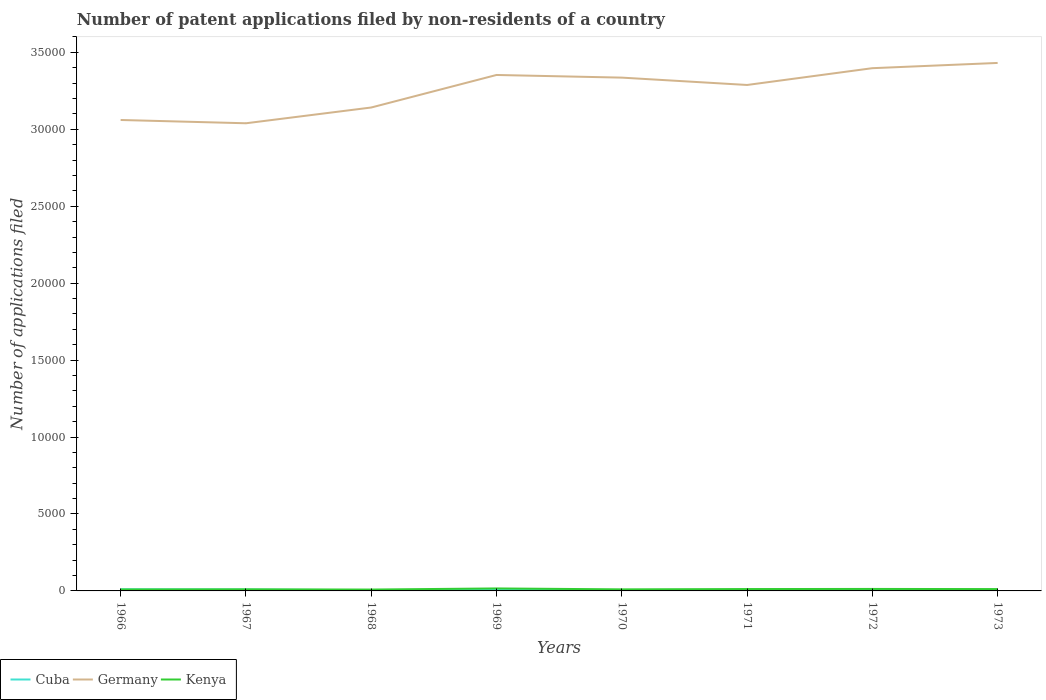Does the line corresponding to Cuba intersect with the line corresponding to Germany?
Your answer should be compact. No. Across all years, what is the maximum number of applications filed in Germany?
Your answer should be very brief. 3.04e+04. In which year was the number of applications filed in Kenya maximum?
Keep it short and to the point. 1968. What is the difference between the highest and the second highest number of applications filed in Germany?
Your answer should be very brief. 3921. How many years are there in the graph?
Provide a short and direct response. 8. Does the graph contain any zero values?
Give a very brief answer. No. Does the graph contain grids?
Offer a terse response. No. Where does the legend appear in the graph?
Your answer should be compact. Bottom left. What is the title of the graph?
Your answer should be compact. Number of patent applications filed by non-residents of a country. What is the label or title of the Y-axis?
Provide a succinct answer. Number of applications filed. What is the Number of applications filed in Cuba in 1966?
Your response must be concise. 106. What is the Number of applications filed of Germany in 1966?
Offer a terse response. 3.06e+04. What is the Number of applications filed in Kenya in 1966?
Provide a succinct answer. 93. What is the Number of applications filed of Cuba in 1967?
Your answer should be compact. 90. What is the Number of applications filed of Germany in 1967?
Offer a terse response. 3.04e+04. What is the Number of applications filed of Kenya in 1967?
Your answer should be very brief. 104. What is the Number of applications filed of Germany in 1968?
Your answer should be very brief. 3.14e+04. What is the Number of applications filed of Kenya in 1968?
Your answer should be very brief. 89. What is the Number of applications filed in Germany in 1969?
Your response must be concise. 3.35e+04. What is the Number of applications filed of Kenya in 1969?
Offer a terse response. 161. What is the Number of applications filed of Germany in 1970?
Your answer should be compact. 3.34e+04. What is the Number of applications filed of Kenya in 1970?
Provide a succinct answer. 102. What is the Number of applications filed in Cuba in 1971?
Make the answer very short. 64. What is the Number of applications filed in Germany in 1971?
Keep it short and to the point. 3.29e+04. What is the Number of applications filed of Kenya in 1971?
Keep it short and to the point. 122. What is the Number of applications filed in Cuba in 1972?
Your answer should be compact. 49. What is the Number of applications filed in Germany in 1972?
Provide a succinct answer. 3.40e+04. What is the Number of applications filed of Kenya in 1972?
Offer a terse response. 129. What is the Number of applications filed of Germany in 1973?
Make the answer very short. 3.43e+04. What is the Number of applications filed of Kenya in 1973?
Ensure brevity in your answer.  120. Across all years, what is the maximum Number of applications filed in Cuba?
Ensure brevity in your answer.  106. Across all years, what is the maximum Number of applications filed of Germany?
Provide a short and direct response. 3.43e+04. Across all years, what is the maximum Number of applications filed in Kenya?
Offer a terse response. 161. Across all years, what is the minimum Number of applications filed of Cuba?
Give a very brief answer. 46. Across all years, what is the minimum Number of applications filed of Germany?
Give a very brief answer. 3.04e+04. Across all years, what is the minimum Number of applications filed in Kenya?
Give a very brief answer. 89. What is the total Number of applications filed of Cuba in the graph?
Your answer should be compact. 543. What is the total Number of applications filed in Germany in the graph?
Give a very brief answer. 2.60e+05. What is the total Number of applications filed in Kenya in the graph?
Make the answer very short. 920. What is the difference between the Number of applications filed in Germany in 1966 and that in 1967?
Provide a succinct answer. 214. What is the difference between the Number of applications filed in Cuba in 1966 and that in 1968?
Give a very brief answer. 60. What is the difference between the Number of applications filed in Germany in 1966 and that in 1968?
Ensure brevity in your answer.  -810. What is the difference between the Number of applications filed of Cuba in 1966 and that in 1969?
Give a very brief answer. 38. What is the difference between the Number of applications filed of Germany in 1966 and that in 1969?
Offer a terse response. -2925. What is the difference between the Number of applications filed of Kenya in 1966 and that in 1969?
Ensure brevity in your answer.  -68. What is the difference between the Number of applications filed in Germany in 1966 and that in 1970?
Provide a short and direct response. -2753. What is the difference between the Number of applications filed in Cuba in 1966 and that in 1971?
Make the answer very short. 42. What is the difference between the Number of applications filed of Germany in 1966 and that in 1971?
Provide a short and direct response. -2275. What is the difference between the Number of applications filed in Germany in 1966 and that in 1972?
Your answer should be very brief. -3366. What is the difference between the Number of applications filed of Kenya in 1966 and that in 1972?
Your response must be concise. -36. What is the difference between the Number of applications filed in Cuba in 1966 and that in 1973?
Give a very brief answer. 47. What is the difference between the Number of applications filed of Germany in 1966 and that in 1973?
Your answer should be very brief. -3707. What is the difference between the Number of applications filed of Germany in 1967 and that in 1968?
Your answer should be compact. -1024. What is the difference between the Number of applications filed in Kenya in 1967 and that in 1968?
Your answer should be compact. 15. What is the difference between the Number of applications filed in Germany in 1967 and that in 1969?
Your answer should be very brief. -3139. What is the difference between the Number of applications filed of Kenya in 1967 and that in 1969?
Keep it short and to the point. -57. What is the difference between the Number of applications filed of Cuba in 1967 and that in 1970?
Offer a very short reply. 29. What is the difference between the Number of applications filed in Germany in 1967 and that in 1970?
Ensure brevity in your answer.  -2967. What is the difference between the Number of applications filed in Germany in 1967 and that in 1971?
Your response must be concise. -2489. What is the difference between the Number of applications filed in Kenya in 1967 and that in 1971?
Provide a short and direct response. -18. What is the difference between the Number of applications filed in Germany in 1967 and that in 1972?
Your response must be concise. -3580. What is the difference between the Number of applications filed in Kenya in 1967 and that in 1972?
Give a very brief answer. -25. What is the difference between the Number of applications filed of Cuba in 1967 and that in 1973?
Provide a short and direct response. 31. What is the difference between the Number of applications filed in Germany in 1967 and that in 1973?
Your answer should be very brief. -3921. What is the difference between the Number of applications filed of Kenya in 1967 and that in 1973?
Give a very brief answer. -16. What is the difference between the Number of applications filed of Cuba in 1968 and that in 1969?
Ensure brevity in your answer.  -22. What is the difference between the Number of applications filed of Germany in 1968 and that in 1969?
Keep it short and to the point. -2115. What is the difference between the Number of applications filed in Kenya in 1968 and that in 1969?
Provide a succinct answer. -72. What is the difference between the Number of applications filed in Cuba in 1968 and that in 1970?
Your response must be concise. -15. What is the difference between the Number of applications filed of Germany in 1968 and that in 1970?
Your answer should be compact. -1943. What is the difference between the Number of applications filed of Cuba in 1968 and that in 1971?
Provide a short and direct response. -18. What is the difference between the Number of applications filed of Germany in 1968 and that in 1971?
Give a very brief answer. -1465. What is the difference between the Number of applications filed of Kenya in 1968 and that in 1971?
Your answer should be very brief. -33. What is the difference between the Number of applications filed of Cuba in 1968 and that in 1972?
Ensure brevity in your answer.  -3. What is the difference between the Number of applications filed in Germany in 1968 and that in 1972?
Give a very brief answer. -2556. What is the difference between the Number of applications filed in Germany in 1968 and that in 1973?
Keep it short and to the point. -2897. What is the difference between the Number of applications filed of Kenya in 1968 and that in 1973?
Your response must be concise. -31. What is the difference between the Number of applications filed of Cuba in 1969 and that in 1970?
Give a very brief answer. 7. What is the difference between the Number of applications filed of Germany in 1969 and that in 1970?
Offer a terse response. 172. What is the difference between the Number of applications filed of Kenya in 1969 and that in 1970?
Your answer should be very brief. 59. What is the difference between the Number of applications filed in Germany in 1969 and that in 1971?
Ensure brevity in your answer.  650. What is the difference between the Number of applications filed of Kenya in 1969 and that in 1971?
Make the answer very short. 39. What is the difference between the Number of applications filed in Cuba in 1969 and that in 1972?
Offer a terse response. 19. What is the difference between the Number of applications filed in Germany in 1969 and that in 1972?
Provide a short and direct response. -441. What is the difference between the Number of applications filed of Kenya in 1969 and that in 1972?
Provide a succinct answer. 32. What is the difference between the Number of applications filed in Germany in 1969 and that in 1973?
Provide a short and direct response. -782. What is the difference between the Number of applications filed in Kenya in 1969 and that in 1973?
Offer a terse response. 41. What is the difference between the Number of applications filed in Cuba in 1970 and that in 1971?
Your response must be concise. -3. What is the difference between the Number of applications filed of Germany in 1970 and that in 1971?
Provide a short and direct response. 478. What is the difference between the Number of applications filed of Kenya in 1970 and that in 1971?
Make the answer very short. -20. What is the difference between the Number of applications filed of Cuba in 1970 and that in 1972?
Offer a very short reply. 12. What is the difference between the Number of applications filed of Germany in 1970 and that in 1972?
Make the answer very short. -613. What is the difference between the Number of applications filed in Germany in 1970 and that in 1973?
Provide a succinct answer. -954. What is the difference between the Number of applications filed of Cuba in 1971 and that in 1972?
Give a very brief answer. 15. What is the difference between the Number of applications filed in Germany in 1971 and that in 1972?
Provide a short and direct response. -1091. What is the difference between the Number of applications filed of Germany in 1971 and that in 1973?
Make the answer very short. -1432. What is the difference between the Number of applications filed in Kenya in 1971 and that in 1973?
Your answer should be very brief. 2. What is the difference between the Number of applications filed of Cuba in 1972 and that in 1973?
Offer a very short reply. -10. What is the difference between the Number of applications filed of Germany in 1972 and that in 1973?
Give a very brief answer. -341. What is the difference between the Number of applications filed in Cuba in 1966 and the Number of applications filed in Germany in 1967?
Offer a very short reply. -3.03e+04. What is the difference between the Number of applications filed of Cuba in 1966 and the Number of applications filed of Kenya in 1967?
Provide a short and direct response. 2. What is the difference between the Number of applications filed in Germany in 1966 and the Number of applications filed in Kenya in 1967?
Make the answer very short. 3.05e+04. What is the difference between the Number of applications filed of Cuba in 1966 and the Number of applications filed of Germany in 1968?
Your response must be concise. -3.13e+04. What is the difference between the Number of applications filed of Cuba in 1966 and the Number of applications filed of Kenya in 1968?
Offer a terse response. 17. What is the difference between the Number of applications filed of Germany in 1966 and the Number of applications filed of Kenya in 1968?
Provide a short and direct response. 3.05e+04. What is the difference between the Number of applications filed of Cuba in 1966 and the Number of applications filed of Germany in 1969?
Ensure brevity in your answer.  -3.34e+04. What is the difference between the Number of applications filed in Cuba in 1966 and the Number of applications filed in Kenya in 1969?
Provide a short and direct response. -55. What is the difference between the Number of applications filed of Germany in 1966 and the Number of applications filed of Kenya in 1969?
Give a very brief answer. 3.04e+04. What is the difference between the Number of applications filed of Cuba in 1966 and the Number of applications filed of Germany in 1970?
Offer a very short reply. -3.33e+04. What is the difference between the Number of applications filed of Cuba in 1966 and the Number of applications filed of Kenya in 1970?
Provide a succinct answer. 4. What is the difference between the Number of applications filed of Germany in 1966 and the Number of applications filed of Kenya in 1970?
Provide a succinct answer. 3.05e+04. What is the difference between the Number of applications filed of Cuba in 1966 and the Number of applications filed of Germany in 1971?
Ensure brevity in your answer.  -3.28e+04. What is the difference between the Number of applications filed in Cuba in 1966 and the Number of applications filed in Kenya in 1971?
Make the answer very short. -16. What is the difference between the Number of applications filed in Germany in 1966 and the Number of applications filed in Kenya in 1971?
Make the answer very short. 3.05e+04. What is the difference between the Number of applications filed of Cuba in 1966 and the Number of applications filed of Germany in 1972?
Provide a succinct answer. -3.39e+04. What is the difference between the Number of applications filed in Germany in 1966 and the Number of applications filed in Kenya in 1972?
Make the answer very short. 3.05e+04. What is the difference between the Number of applications filed in Cuba in 1966 and the Number of applications filed in Germany in 1973?
Ensure brevity in your answer.  -3.42e+04. What is the difference between the Number of applications filed in Cuba in 1966 and the Number of applications filed in Kenya in 1973?
Give a very brief answer. -14. What is the difference between the Number of applications filed in Germany in 1966 and the Number of applications filed in Kenya in 1973?
Ensure brevity in your answer.  3.05e+04. What is the difference between the Number of applications filed of Cuba in 1967 and the Number of applications filed of Germany in 1968?
Your response must be concise. -3.13e+04. What is the difference between the Number of applications filed of Germany in 1967 and the Number of applications filed of Kenya in 1968?
Make the answer very short. 3.03e+04. What is the difference between the Number of applications filed of Cuba in 1967 and the Number of applications filed of Germany in 1969?
Your answer should be compact. -3.34e+04. What is the difference between the Number of applications filed of Cuba in 1967 and the Number of applications filed of Kenya in 1969?
Provide a short and direct response. -71. What is the difference between the Number of applications filed in Germany in 1967 and the Number of applications filed in Kenya in 1969?
Make the answer very short. 3.02e+04. What is the difference between the Number of applications filed in Cuba in 1967 and the Number of applications filed in Germany in 1970?
Your response must be concise. -3.33e+04. What is the difference between the Number of applications filed of Cuba in 1967 and the Number of applications filed of Kenya in 1970?
Offer a terse response. -12. What is the difference between the Number of applications filed of Germany in 1967 and the Number of applications filed of Kenya in 1970?
Make the answer very short. 3.03e+04. What is the difference between the Number of applications filed in Cuba in 1967 and the Number of applications filed in Germany in 1971?
Give a very brief answer. -3.28e+04. What is the difference between the Number of applications filed in Cuba in 1967 and the Number of applications filed in Kenya in 1971?
Your response must be concise. -32. What is the difference between the Number of applications filed in Germany in 1967 and the Number of applications filed in Kenya in 1971?
Provide a succinct answer. 3.03e+04. What is the difference between the Number of applications filed in Cuba in 1967 and the Number of applications filed in Germany in 1972?
Make the answer very short. -3.39e+04. What is the difference between the Number of applications filed of Cuba in 1967 and the Number of applications filed of Kenya in 1972?
Keep it short and to the point. -39. What is the difference between the Number of applications filed in Germany in 1967 and the Number of applications filed in Kenya in 1972?
Your response must be concise. 3.03e+04. What is the difference between the Number of applications filed of Cuba in 1967 and the Number of applications filed of Germany in 1973?
Provide a short and direct response. -3.42e+04. What is the difference between the Number of applications filed in Cuba in 1967 and the Number of applications filed in Kenya in 1973?
Provide a short and direct response. -30. What is the difference between the Number of applications filed of Germany in 1967 and the Number of applications filed of Kenya in 1973?
Offer a very short reply. 3.03e+04. What is the difference between the Number of applications filed of Cuba in 1968 and the Number of applications filed of Germany in 1969?
Make the answer very short. -3.35e+04. What is the difference between the Number of applications filed in Cuba in 1968 and the Number of applications filed in Kenya in 1969?
Keep it short and to the point. -115. What is the difference between the Number of applications filed in Germany in 1968 and the Number of applications filed in Kenya in 1969?
Ensure brevity in your answer.  3.13e+04. What is the difference between the Number of applications filed of Cuba in 1968 and the Number of applications filed of Germany in 1970?
Your answer should be very brief. -3.33e+04. What is the difference between the Number of applications filed in Cuba in 1968 and the Number of applications filed in Kenya in 1970?
Your answer should be very brief. -56. What is the difference between the Number of applications filed in Germany in 1968 and the Number of applications filed in Kenya in 1970?
Ensure brevity in your answer.  3.13e+04. What is the difference between the Number of applications filed of Cuba in 1968 and the Number of applications filed of Germany in 1971?
Offer a very short reply. -3.28e+04. What is the difference between the Number of applications filed of Cuba in 1968 and the Number of applications filed of Kenya in 1971?
Offer a terse response. -76. What is the difference between the Number of applications filed of Germany in 1968 and the Number of applications filed of Kenya in 1971?
Offer a terse response. 3.13e+04. What is the difference between the Number of applications filed of Cuba in 1968 and the Number of applications filed of Germany in 1972?
Offer a very short reply. -3.39e+04. What is the difference between the Number of applications filed in Cuba in 1968 and the Number of applications filed in Kenya in 1972?
Offer a very short reply. -83. What is the difference between the Number of applications filed of Germany in 1968 and the Number of applications filed of Kenya in 1972?
Provide a short and direct response. 3.13e+04. What is the difference between the Number of applications filed of Cuba in 1968 and the Number of applications filed of Germany in 1973?
Your answer should be compact. -3.43e+04. What is the difference between the Number of applications filed of Cuba in 1968 and the Number of applications filed of Kenya in 1973?
Your answer should be compact. -74. What is the difference between the Number of applications filed in Germany in 1968 and the Number of applications filed in Kenya in 1973?
Keep it short and to the point. 3.13e+04. What is the difference between the Number of applications filed in Cuba in 1969 and the Number of applications filed in Germany in 1970?
Give a very brief answer. -3.33e+04. What is the difference between the Number of applications filed of Cuba in 1969 and the Number of applications filed of Kenya in 1970?
Your answer should be compact. -34. What is the difference between the Number of applications filed of Germany in 1969 and the Number of applications filed of Kenya in 1970?
Ensure brevity in your answer.  3.34e+04. What is the difference between the Number of applications filed of Cuba in 1969 and the Number of applications filed of Germany in 1971?
Your answer should be compact. -3.28e+04. What is the difference between the Number of applications filed in Cuba in 1969 and the Number of applications filed in Kenya in 1971?
Give a very brief answer. -54. What is the difference between the Number of applications filed of Germany in 1969 and the Number of applications filed of Kenya in 1971?
Keep it short and to the point. 3.34e+04. What is the difference between the Number of applications filed of Cuba in 1969 and the Number of applications filed of Germany in 1972?
Your response must be concise. -3.39e+04. What is the difference between the Number of applications filed of Cuba in 1969 and the Number of applications filed of Kenya in 1972?
Ensure brevity in your answer.  -61. What is the difference between the Number of applications filed of Germany in 1969 and the Number of applications filed of Kenya in 1972?
Ensure brevity in your answer.  3.34e+04. What is the difference between the Number of applications filed of Cuba in 1969 and the Number of applications filed of Germany in 1973?
Your answer should be very brief. -3.42e+04. What is the difference between the Number of applications filed of Cuba in 1969 and the Number of applications filed of Kenya in 1973?
Offer a terse response. -52. What is the difference between the Number of applications filed in Germany in 1969 and the Number of applications filed in Kenya in 1973?
Offer a very short reply. 3.34e+04. What is the difference between the Number of applications filed of Cuba in 1970 and the Number of applications filed of Germany in 1971?
Provide a short and direct response. -3.28e+04. What is the difference between the Number of applications filed in Cuba in 1970 and the Number of applications filed in Kenya in 1971?
Your response must be concise. -61. What is the difference between the Number of applications filed of Germany in 1970 and the Number of applications filed of Kenya in 1971?
Provide a succinct answer. 3.32e+04. What is the difference between the Number of applications filed of Cuba in 1970 and the Number of applications filed of Germany in 1972?
Make the answer very short. -3.39e+04. What is the difference between the Number of applications filed of Cuba in 1970 and the Number of applications filed of Kenya in 1972?
Provide a short and direct response. -68. What is the difference between the Number of applications filed of Germany in 1970 and the Number of applications filed of Kenya in 1972?
Provide a short and direct response. 3.32e+04. What is the difference between the Number of applications filed of Cuba in 1970 and the Number of applications filed of Germany in 1973?
Keep it short and to the point. -3.43e+04. What is the difference between the Number of applications filed in Cuba in 1970 and the Number of applications filed in Kenya in 1973?
Give a very brief answer. -59. What is the difference between the Number of applications filed in Germany in 1970 and the Number of applications filed in Kenya in 1973?
Your answer should be compact. 3.32e+04. What is the difference between the Number of applications filed in Cuba in 1971 and the Number of applications filed in Germany in 1972?
Your answer should be very brief. -3.39e+04. What is the difference between the Number of applications filed of Cuba in 1971 and the Number of applications filed of Kenya in 1972?
Your answer should be compact. -65. What is the difference between the Number of applications filed in Germany in 1971 and the Number of applications filed in Kenya in 1972?
Provide a succinct answer. 3.28e+04. What is the difference between the Number of applications filed in Cuba in 1971 and the Number of applications filed in Germany in 1973?
Give a very brief answer. -3.42e+04. What is the difference between the Number of applications filed in Cuba in 1971 and the Number of applications filed in Kenya in 1973?
Offer a very short reply. -56. What is the difference between the Number of applications filed in Germany in 1971 and the Number of applications filed in Kenya in 1973?
Your answer should be compact. 3.28e+04. What is the difference between the Number of applications filed of Cuba in 1972 and the Number of applications filed of Germany in 1973?
Keep it short and to the point. -3.43e+04. What is the difference between the Number of applications filed in Cuba in 1972 and the Number of applications filed in Kenya in 1973?
Provide a succinct answer. -71. What is the difference between the Number of applications filed of Germany in 1972 and the Number of applications filed of Kenya in 1973?
Your response must be concise. 3.39e+04. What is the average Number of applications filed of Cuba per year?
Provide a short and direct response. 67.88. What is the average Number of applications filed in Germany per year?
Your response must be concise. 3.26e+04. What is the average Number of applications filed in Kenya per year?
Offer a terse response. 115. In the year 1966, what is the difference between the Number of applications filed in Cuba and Number of applications filed in Germany?
Ensure brevity in your answer.  -3.05e+04. In the year 1966, what is the difference between the Number of applications filed of Germany and Number of applications filed of Kenya?
Your answer should be compact. 3.05e+04. In the year 1967, what is the difference between the Number of applications filed of Cuba and Number of applications filed of Germany?
Ensure brevity in your answer.  -3.03e+04. In the year 1967, what is the difference between the Number of applications filed of Germany and Number of applications filed of Kenya?
Your answer should be very brief. 3.03e+04. In the year 1968, what is the difference between the Number of applications filed in Cuba and Number of applications filed in Germany?
Offer a very short reply. -3.14e+04. In the year 1968, what is the difference between the Number of applications filed in Cuba and Number of applications filed in Kenya?
Your answer should be very brief. -43. In the year 1968, what is the difference between the Number of applications filed in Germany and Number of applications filed in Kenya?
Ensure brevity in your answer.  3.13e+04. In the year 1969, what is the difference between the Number of applications filed in Cuba and Number of applications filed in Germany?
Your answer should be compact. -3.35e+04. In the year 1969, what is the difference between the Number of applications filed of Cuba and Number of applications filed of Kenya?
Provide a succinct answer. -93. In the year 1969, what is the difference between the Number of applications filed of Germany and Number of applications filed of Kenya?
Provide a succinct answer. 3.34e+04. In the year 1970, what is the difference between the Number of applications filed of Cuba and Number of applications filed of Germany?
Give a very brief answer. -3.33e+04. In the year 1970, what is the difference between the Number of applications filed of Cuba and Number of applications filed of Kenya?
Your response must be concise. -41. In the year 1970, what is the difference between the Number of applications filed in Germany and Number of applications filed in Kenya?
Your answer should be compact. 3.33e+04. In the year 1971, what is the difference between the Number of applications filed of Cuba and Number of applications filed of Germany?
Give a very brief answer. -3.28e+04. In the year 1971, what is the difference between the Number of applications filed of Cuba and Number of applications filed of Kenya?
Offer a very short reply. -58. In the year 1971, what is the difference between the Number of applications filed in Germany and Number of applications filed in Kenya?
Offer a very short reply. 3.28e+04. In the year 1972, what is the difference between the Number of applications filed in Cuba and Number of applications filed in Germany?
Your response must be concise. -3.39e+04. In the year 1972, what is the difference between the Number of applications filed in Cuba and Number of applications filed in Kenya?
Your answer should be very brief. -80. In the year 1972, what is the difference between the Number of applications filed in Germany and Number of applications filed in Kenya?
Provide a succinct answer. 3.38e+04. In the year 1973, what is the difference between the Number of applications filed of Cuba and Number of applications filed of Germany?
Keep it short and to the point. -3.43e+04. In the year 1973, what is the difference between the Number of applications filed of Cuba and Number of applications filed of Kenya?
Your answer should be very brief. -61. In the year 1973, what is the difference between the Number of applications filed in Germany and Number of applications filed in Kenya?
Your answer should be very brief. 3.42e+04. What is the ratio of the Number of applications filed in Cuba in 1966 to that in 1967?
Offer a very short reply. 1.18. What is the ratio of the Number of applications filed in Kenya in 1966 to that in 1967?
Your answer should be very brief. 0.89. What is the ratio of the Number of applications filed of Cuba in 1966 to that in 1968?
Your answer should be very brief. 2.3. What is the ratio of the Number of applications filed in Germany in 1966 to that in 1968?
Your answer should be compact. 0.97. What is the ratio of the Number of applications filed in Kenya in 1966 to that in 1968?
Ensure brevity in your answer.  1.04. What is the ratio of the Number of applications filed in Cuba in 1966 to that in 1969?
Provide a short and direct response. 1.56. What is the ratio of the Number of applications filed in Germany in 1966 to that in 1969?
Make the answer very short. 0.91. What is the ratio of the Number of applications filed of Kenya in 1966 to that in 1969?
Offer a very short reply. 0.58. What is the ratio of the Number of applications filed in Cuba in 1966 to that in 1970?
Offer a very short reply. 1.74. What is the ratio of the Number of applications filed of Germany in 1966 to that in 1970?
Your answer should be compact. 0.92. What is the ratio of the Number of applications filed in Kenya in 1966 to that in 1970?
Your answer should be compact. 0.91. What is the ratio of the Number of applications filed of Cuba in 1966 to that in 1971?
Your answer should be very brief. 1.66. What is the ratio of the Number of applications filed in Germany in 1966 to that in 1971?
Your answer should be compact. 0.93. What is the ratio of the Number of applications filed of Kenya in 1966 to that in 1971?
Your answer should be compact. 0.76. What is the ratio of the Number of applications filed in Cuba in 1966 to that in 1972?
Offer a terse response. 2.16. What is the ratio of the Number of applications filed of Germany in 1966 to that in 1972?
Make the answer very short. 0.9. What is the ratio of the Number of applications filed of Kenya in 1966 to that in 1972?
Provide a succinct answer. 0.72. What is the ratio of the Number of applications filed of Cuba in 1966 to that in 1973?
Ensure brevity in your answer.  1.8. What is the ratio of the Number of applications filed of Germany in 1966 to that in 1973?
Provide a succinct answer. 0.89. What is the ratio of the Number of applications filed of Kenya in 1966 to that in 1973?
Ensure brevity in your answer.  0.78. What is the ratio of the Number of applications filed in Cuba in 1967 to that in 1968?
Keep it short and to the point. 1.96. What is the ratio of the Number of applications filed of Germany in 1967 to that in 1968?
Your answer should be compact. 0.97. What is the ratio of the Number of applications filed in Kenya in 1967 to that in 1968?
Your answer should be very brief. 1.17. What is the ratio of the Number of applications filed in Cuba in 1967 to that in 1969?
Provide a short and direct response. 1.32. What is the ratio of the Number of applications filed of Germany in 1967 to that in 1969?
Keep it short and to the point. 0.91. What is the ratio of the Number of applications filed in Kenya in 1967 to that in 1969?
Offer a very short reply. 0.65. What is the ratio of the Number of applications filed of Cuba in 1967 to that in 1970?
Give a very brief answer. 1.48. What is the ratio of the Number of applications filed in Germany in 1967 to that in 1970?
Make the answer very short. 0.91. What is the ratio of the Number of applications filed of Kenya in 1967 to that in 1970?
Make the answer very short. 1.02. What is the ratio of the Number of applications filed in Cuba in 1967 to that in 1971?
Make the answer very short. 1.41. What is the ratio of the Number of applications filed in Germany in 1967 to that in 1971?
Give a very brief answer. 0.92. What is the ratio of the Number of applications filed in Kenya in 1967 to that in 1971?
Keep it short and to the point. 0.85. What is the ratio of the Number of applications filed of Cuba in 1967 to that in 1972?
Provide a short and direct response. 1.84. What is the ratio of the Number of applications filed in Germany in 1967 to that in 1972?
Give a very brief answer. 0.89. What is the ratio of the Number of applications filed in Kenya in 1967 to that in 1972?
Keep it short and to the point. 0.81. What is the ratio of the Number of applications filed of Cuba in 1967 to that in 1973?
Your answer should be very brief. 1.53. What is the ratio of the Number of applications filed in Germany in 1967 to that in 1973?
Your response must be concise. 0.89. What is the ratio of the Number of applications filed in Kenya in 1967 to that in 1973?
Your response must be concise. 0.87. What is the ratio of the Number of applications filed in Cuba in 1968 to that in 1969?
Offer a very short reply. 0.68. What is the ratio of the Number of applications filed in Germany in 1968 to that in 1969?
Your answer should be compact. 0.94. What is the ratio of the Number of applications filed in Kenya in 1968 to that in 1969?
Your answer should be very brief. 0.55. What is the ratio of the Number of applications filed in Cuba in 1968 to that in 1970?
Offer a terse response. 0.75. What is the ratio of the Number of applications filed in Germany in 1968 to that in 1970?
Give a very brief answer. 0.94. What is the ratio of the Number of applications filed in Kenya in 1968 to that in 1970?
Offer a terse response. 0.87. What is the ratio of the Number of applications filed in Cuba in 1968 to that in 1971?
Your answer should be compact. 0.72. What is the ratio of the Number of applications filed in Germany in 1968 to that in 1971?
Offer a terse response. 0.96. What is the ratio of the Number of applications filed of Kenya in 1968 to that in 1971?
Your answer should be compact. 0.73. What is the ratio of the Number of applications filed of Cuba in 1968 to that in 1972?
Make the answer very short. 0.94. What is the ratio of the Number of applications filed in Germany in 1968 to that in 1972?
Your answer should be very brief. 0.92. What is the ratio of the Number of applications filed in Kenya in 1968 to that in 1972?
Your answer should be compact. 0.69. What is the ratio of the Number of applications filed of Cuba in 1968 to that in 1973?
Your answer should be compact. 0.78. What is the ratio of the Number of applications filed of Germany in 1968 to that in 1973?
Ensure brevity in your answer.  0.92. What is the ratio of the Number of applications filed in Kenya in 1968 to that in 1973?
Offer a terse response. 0.74. What is the ratio of the Number of applications filed of Cuba in 1969 to that in 1970?
Make the answer very short. 1.11. What is the ratio of the Number of applications filed in Germany in 1969 to that in 1970?
Provide a short and direct response. 1.01. What is the ratio of the Number of applications filed of Kenya in 1969 to that in 1970?
Offer a terse response. 1.58. What is the ratio of the Number of applications filed in Cuba in 1969 to that in 1971?
Your response must be concise. 1.06. What is the ratio of the Number of applications filed of Germany in 1969 to that in 1971?
Offer a terse response. 1.02. What is the ratio of the Number of applications filed of Kenya in 1969 to that in 1971?
Keep it short and to the point. 1.32. What is the ratio of the Number of applications filed in Cuba in 1969 to that in 1972?
Offer a very short reply. 1.39. What is the ratio of the Number of applications filed of Germany in 1969 to that in 1972?
Provide a succinct answer. 0.99. What is the ratio of the Number of applications filed in Kenya in 1969 to that in 1972?
Make the answer very short. 1.25. What is the ratio of the Number of applications filed in Cuba in 1969 to that in 1973?
Give a very brief answer. 1.15. What is the ratio of the Number of applications filed of Germany in 1969 to that in 1973?
Keep it short and to the point. 0.98. What is the ratio of the Number of applications filed in Kenya in 1969 to that in 1973?
Ensure brevity in your answer.  1.34. What is the ratio of the Number of applications filed in Cuba in 1970 to that in 1971?
Offer a terse response. 0.95. What is the ratio of the Number of applications filed of Germany in 1970 to that in 1971?
Make the answer very short. 1.01. What is the ratio of the Number of applications filed in Kenya in 1970 to that in 1971?
Offer a terse response. 0.84. What is the ratio of the Number of applications filed in Cuba in 1970 to that in 1972?
Offer a terse response. 1.24. What is the ratio of the Number of applications filed in Kenya in 1970 to that in 1972?
Make the answer very short. 0.79. What is the ratio of the Number of applications filed in Cuba in 1970 to that in 1973?
Make the answer very short. 1.03. What is the ratio of the Number of applications filed in Germany in 1970 to that in 1973?
Your answer should be compact. 0.97. What is the ratio of the Number of applications filed of Kenya in 1970 to that in 1973?
Provide a succinct answer. 0.85. What is the ratio of the Number of applications filed in Cuba in 1971 to that in 1972?
Offer a very short reply. 1.31. What is the ratio of the Number of applications filed in Germany in 1971 to that in 1972?
Provide a short and direct response. 0.97. What is the ratio of the Number of applications filed in Kenya in 1971 to that in 1972?
Give a very brief answer. 0.95. What is the ratio of the Number of applications filed of Cuba in 1971 to that in 1973?
Your answer should be very brief. 1.08. What is the ratio of the Number of applications filed of Germany in 1971 to that in 1973?
Your response must be concise. 0.96. What is the ratio of the Number of applications filed in Kenya in 1971 to that in 1973?
Your answer should be compact. 1.02. What is the ratio of the Number of applications filed of Cuba in 1972 to that in 1973?
Your response must be concise. 0.83. What is the ratio of the Number of applications filed of Germany in 1972 to that in 1973?
Offer a terse response. 0.99. What is the ratio of the Number of applications filed of Kenya in 1972 to that in 1973?
Ensure brevity in your answer.  1.07. What is the difference between the highest and the second highest Number of applications filed in Cuba?
Keep it short and to the point. 16. What is the difference between the highest and the second highest Number of applications filed of Germany?
Ensure brevity in your answer.  341. What is the difference between the highest and the second highest Number of applications filed in Kenya?
Your answer should be very brief. 32. What is the difference between the highest and the lowest Number of applications filed of Germany?
Provide a succinct answer. 3921. What is the difference between the highest and the lowest Number of applications filed of Kenya?
Give a very brief answer. 72. 